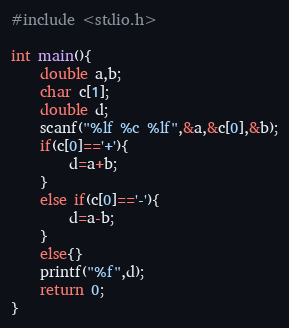Convert code to text. <code><loc_0><loc_0><loc_500><loc_500><_C_>#include <stdio.h>

int main(){
    double a,b;
    char c[1];
    double d;
    scanf("%lf %c %lf",&a,&c[0],&b);
    if(c[0]=='+'){
        d=a+b;
    }
    else if(c[0]=='-'){
        d=a-b;
    }
    else{}
    printf("%f",d);
    return 0;
}</code> 